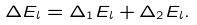<formula> <loc_0><loc_0><loc_500><loc_500>\Delta E _ { l } = \Delta _ { 1 } E _ { l } + \Delta _ { 2 } E _ { l } .</formula> 